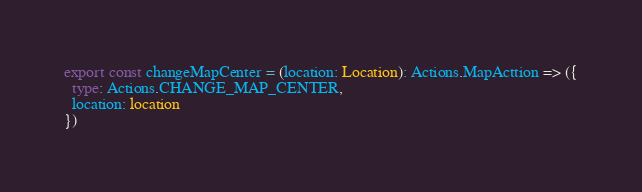Convert code to text. <code><loc_0><loc_0><loc_500><loc_500><_TypeScript_>export const changeMapCenter = (location: Location): Actions.MapActtion => ({
  type: Actions.CHANGE_MAP_CENTER,
  location: location
})</code> 